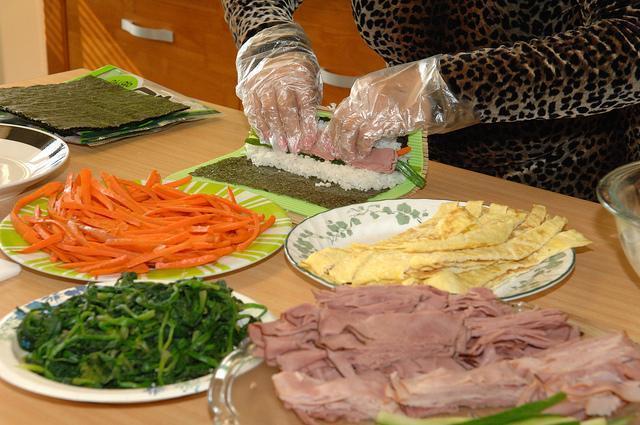How many bowls are there?
Give a very brief answer. 1. How many dining tables are visible?
Give a very brief answer. 1. How many carrots can you see?
Give a very brief answer. 1. 